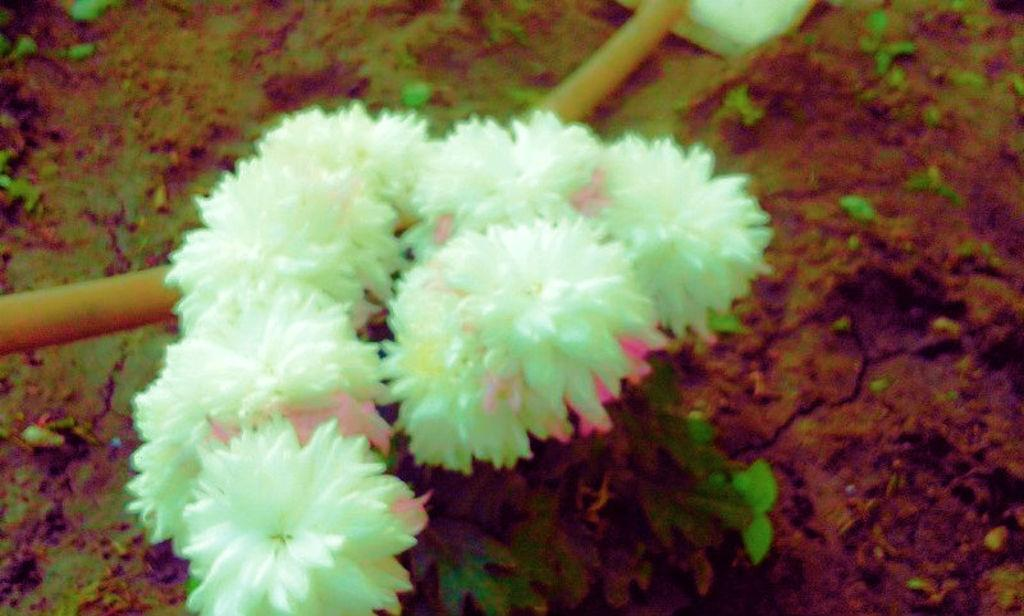What type of plants can be seen in the image? There are flowers in the image. What is visible beneath the flowers? The ground is visible in the image. What type of polish is being applied to the flowers in the image? There is no indication of any polish being applied to the flowers in the image. What type of motion can be observed in the flowers in the image? The flowers are stationary in the image and do not exhibit any motion. 